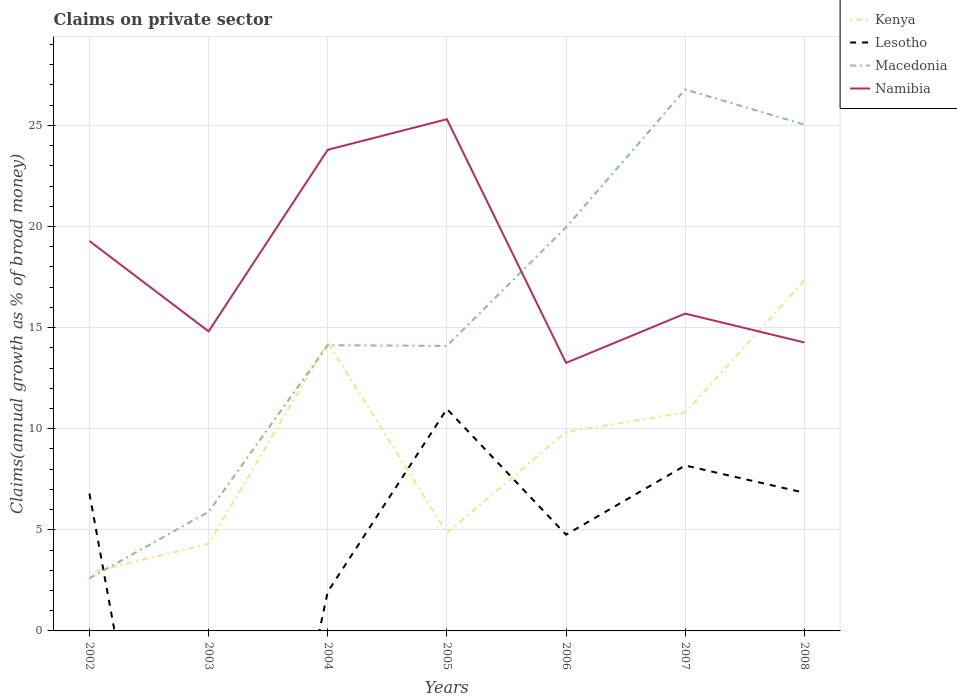How many different coloured lines are there?
Make the answer very short. 4. Is the number of lines equal to the number of legend labels?
Provide a succinct answer. No. Across all years, what is the maximum percentage of broad money claimed on private sector in Macedonia?
Keep it short and to the point. 2.6. What is the total percentage of broad money claimed on private sector in Lesotho in the graph?
Provide a short and direct response. -9.04. What is the difference between the highest and the second highest percentage of broad money claimed on private sector in Namibia?
Make the answer very short. 12.05. What is the difference between the highest and the lowest percentage of broad money claimed on private sector in Kenya?
Keep it short and to the point. 4. Is the percentage of broad money claimed on private sector in Kenya strictly greater than the percentage of broad money claimed on private sector in Lesotho over the years?
Provide a succinct answer. No. How many lines are there?
Ensure brevity in your answer.  4. How many years are there in the graph?
Provide a succinct answer. 7. Are the values on the major ticks of Y-axis written in scientific E-notation?
Provide a short and direct response. No. How are the legend labels stacked?
Give a very brief answer. Vertical. What is the title of the graph?
Your answer should be compact. Claims on private sector. What is the label or title of the Y-axis?
Give a very brief answer. Claims(annual growth as % of broad money). What is the Claims(annual growth as % of broad money) of Kenya in 2002?
Provide a short and direct response. 2.88. What is the Claims(annual growth as % of broad money) of Lesotho in 2002?
Give a very brief answer. 6.79. What is the Claims(annual growth as % of broad money) of Macedonia in 2002?
Your response must be concise. 2.6. What is the Claims(annual growth as % of broad money) of Namibia in 2002?
Make the answer very short. 19.28. What is the Claims(annual growth as % of broad money) in Kenya in 2003?
Your answer should be compact. 4.31. What is the Claims(annual growth as % of broad money) of Lesotho in 2003?
Offer a very short reply. 0. What is the Claims(annual growth as % of broad money) in Macedonia in 2003?
Your answer should be very brief. 5.89. What is the Claims(annual growth as % of broad money) in Namibia in 2003?
Offer a terse response. 14.81. What is the Claims(annual growth as % of broad money) in Kenya in 2004?
Give a very brief answer. 14.27. What is the Claims(annual growth as % of broad money) of Lesotho in 2004?
Ensure brevity in your answer.  1.94. What is the Claims(annual growth as % of broad money) of Macedonia in 2004?
Keep it short and to the point. 14.13. What is the Claims(annual growth as % of broad money) in Namibia in 2004?
Your answer should be compact. 23.79. What is the Claims(annual growth as % of broad money) of Kenya in 2005?
Your answer should be very brief. 4.84. What is the Claims(annual growth as % of broad money) of Lesotho in 2005?
Give a very brief answer. 10.98. What is the Claims(annual growth as % of broad money) of Macedonia in 2005?
Offer a very short reply. 14.1. What is the Claims(annual growth as % of broad money) in Namibia in 2005?
Your answer should be compact. 25.31. What is the Claims(annual growth as % of broad money) of Kenya in 2006?
Provide a succinct answer. 9.84. What is the Claims(annual growth as % of broad money) in Lesotho in 2006?
Provide a short and direct response. 4.76. What is the Claims(annual growth as % of broad money) in Macedonia in 2006?
Provide a succinct answer. 19.96. What is the Claims(annual growth as % of broad money) of Namibia in 2006?
Offer a very short reply. 13.26. What is the Claims(annual growth as % of broad money) of Kenya in 2007?
Provide a succinct answer. 10.8. What is the Claims(annual growth as % of broad money) in Lesotho in 2007?
Provide a short and direct response. 8.18. What is the Claims(annual growth as % of broad money) in Macedonia in 2007?
Offer a very short reply. 26.78. What is the Claims(annual growth as % of broad money) in Namibia in 2007?
Provide a short and direct response. 15.69. What is the Claims(annual growth as % of broad money) in Kenya in 2008?
Your answer should be very brief. 17.33. What is the Claims(annual growth as % of broad money) of Lesotho in 2008?
Provide a short and direct response. 6.83. What is the Claims(annual growth as % of broad money) in Macedonia in 2008?
Give a very brief answer. 25.04. What is the Claims(annual growth as % of broad money) in Namibia in 2008?
Offer a very short reply. 14.27. Across all years, what is the maximum Claims(annual growth as % of broad money) of Kenya?
Ensure brevity in your answer.  17.33. Across all years, what is the maximum Claims(annual growth as % of broad money) in Lesotho?
Your answer should be compact. 10.98. Across all years, what is the maximum Claims(annual growth as % of broad money) in Macedonia?
Offer a terse response. 26.78. Across all years, what is the maximum Claims(annual growth as % of broad money) in Namibia?
Offer a terse response. 25.31. Across all years, what is the minimum Claims(annual growth as % of broad money) in Kenya?
Offer a terse response. 2.88. Across all years, what is the minimum Claims(annual growth as % of broad money) in Lesotho?
Your response must be concise. 0. Across all years, what is the minimum Claims(annual growth as % of broad money) of Macedonia?
Make the answer very short. 2.6. Across all years, what is the minimum Claims(annual growth as % of broad money) of Namibia?
Give a very brief answer. 13.26. What is the total Claims(annual growth as % of broad money) in Kenya in the graph?
Offer a terse response. 64.27. What is the total Claims(annual growth as % of broad money) of Lesotho in the graph?
Your answer should be compact. 39.48. What is the total Claims(annual growth as % of broad money) in Macedonia in the graph?
Make the answer very short. 108.5. What is the total Claims(annual growth as % of broad money) in Namibia in the graph?
Your answer should be compact. 126.41. What is the difference between the Claims(annual growth as % of broad money) of Kenya in 2002 and that in 2003?
Provide a succinct answer. -1.42. What is the difference between the Claims(annual growth as % of broad money) of Macedonia in 2002 and that in 2003?
Offer a terse response. -3.29. What is the difference between the Claims(annual growth as % of broad money) in Namibia in 2002 and that in 2003?
Give a very brief answer. 4.47. What is the difference between the Claims(annual growth as % of broad money) in Kenya in 2002 and that in 2004?
Make the answer very short. -11.39. What is the difference between the Claims(annual growth as % of broad money) of Lesotho in 2002 and that in 2004?
Your response must be concise. 4.86. What is the difference between the Claims(annual growth as % of broad money) in Macedonia in 2002 and that in 2004?
Ensure brevity in your answer.  -11.53. What is the difference between the Claims(annual growth as % of broad money) of Namibia in 2002 and that in 2004?
Make the answer very short. -4.51. What is the difference between the Claims(annual growth as % of broad money) of Kenya in 2002 and that in 2005?
Offer a terse response. -1.96. What is the difference between the Claims(annual growth as % of broad money) of Lesotho in 2002 and that in 2005?
Make the answer very short. -4.18. What is the difference between the Claims(annual growth as % of broad money) in Macedonia in 2002 and that in 2005?
Keep it short and to the point. -11.5. What is the difference between the Claims(annual growth as % of broad money) in Namibia in 2002 and that in 2005?
Keep it short and to the point. -6.02. What is the difference between the Claims(annual growth as % of broad money) of Kenya in 2002 and that in 2006?
Your response must be concise. -6.95. What is the difference between the Claims(annual growth as % of broad money) of Lesotho in 2002 and that in 2006?
Your answer should be compact. 2.03. What is the difference between the Claims(annual growth as % of broad money) in Macedonia in 2002 and that in 2006?
Provide a short and direct response. -17.36. What is the difference between the Claims(annual growth as % of broad money) of Namibia in 2002 and that in 2006?
Provide a short and direct response. 6.03. What is the difference between the Claims(annual growth as % of broad money) in Kenya in 2002 and that in 2007?
Provide a short and direct response. -7.92. What is the difference between the Claims(annual growth as % of broad money) in Lesotho in 2002 and that in 2007?
Provide a succinct answer. -1.39. What is the difference between the Claims(annual growth as % of broad money) in Macedonia in 2002 and that in 2007?
Offer a terse response. -24.18. What is the difference between the Claims(annual growth as % of broad money) of Namibia in 2002 and that in 2007?
Keep it short and to the point. 3.59. What is the difference between the Claims(annual growth as % of broad money) of Kenya in 2002 and that in 2008?
Provide a short and direct response. -14.44. What is the difference between the Claims(annual growth as % of broad money) in Lesotho in 2002 and that in 2008?
Provide a short and direct response. -0.04. What is the difference between the Claims(annual growth as % of broad money) of Macedonia in 2002 and that in 2008?
Give a very brief answer. -22.44. What is the difference between the Claims(annual growth as % of broad money) in Namibia in 2002 and that in 2008?
Your answer should be compact. 5.02. What is the difference between the Claims(annual growth as % of broad money) of Kenya in 2003 and that in 2004?
Offer a terse response. -9.96. What is the difference between the Claims(annual growth as % of broad money) of Macedonia in 2003 and that in 2004?
Your answer should be compact. -8.24. What is the difference between the Claims(annual growth as % of broad money) of Namibia in 2003 and that in 2004?
Keep it short and to the point. -8.98. What is the difference between the Claims(annual growth as % of broad money) of Kenya in 2003 and that in 2005?
Your answer should be very brief. -0.54. What is the difference between the Claims(annual growth as % of broad money) of Macedonia in 2003 and that in 2005?
Keep it short and to the point. -8.2. What is the difference between the Claims(annual growth as % of broad money) of Namibia in 2003 and that in 2005?
Ensure brevity in your answer.  -10.49. What is the difference between the Claims(annual growth as % of broad money) of Kenya in 2003 and that in 2006?
Offer a very short reply. -5.53. What is the difference between the Claims(annual growth as % of broad money) in Macedonia in 2003 and that in 2006?
Keep it short and to the point. -14.07. What is the difference between the Claims(annual growth as % of broad money) of Namibia in 2003 and that in 2006?
Offer a terse response. 1.56. What is the difference between the Claims(annual growth as % of broad money) of Kenya in 2003 and that in 2007?
Make the answer very short. -6.49. What is the difference between the Claims(annual growth as % of broad money) of Macedonia in 2003 and that in 2007?
Offer a terse response. -20.89. What is the difference between the Claims(annual growth as % of broad money) in Namibia in 2003 and that in 2007?
Offer a terse response. -0.88. What is the difference between the Claims(annual growth as % of broad money) in Kenya in 2003 and that in 2008?
Make the answer very short. -13.02. What is the difference between the Claims(annual growth as % of broad money) in Macedonia in 2003 and that in 2008?
Offer a terse response. -19.15. What is the difference between the Claims(annual growth as % of broad money) of Namibia in 2003 and that in 2008?
Provide a succinct answer. 0.55. What is the difference between the Claims(annual growth as % of broad money) of Kenya in 2004 and that in 2005?
Your answer should be compact. 9.43. What is the difference between the Claims(annual growth as % of broad money) in Lesotho in 2004 and that in 2005?
Ensure brevity in your answer.  -9.04. What is the difference between the Claims(annual growth as % of broad money) in Macedonia in 2004 and that in 2005?
Offer a very short reply. 0.03. What is the difference between the Claims(annual growth as % of broad money) in Namibia in 2004 and that in 2005?
Provide a succinct answer. -1.51. What is the difference between the Claims(annual growth as % of broad money) of Kenya in 2004 and that in 2006?
Your response must be concise. 4.43. What is the difference between the Claims(annual growth as % of broad money) of Lesotho in 2004 and that in 2006?
Your response must be concise. -2.82. What is the difference between the Claims(annual growth as % of broad money) in Macedonia in 2004 and that in 2006?
Make the answer very short. -5.83. What is the difference between the Claims(annual growth as % of broad money) in Namibia in 2004 and that in 2006?
Keep it short and to the point. 10.54. What is the difference between the Claims(annual growth as % of broad money) of Kenya in 2004 and that in 2007?
Provide a succinct answer. 3.47. What is the difference between the Claims(annual growth as % of broad money) of Lesotho in 2004 and that in 2007?
Ensure brevity in your answer.  -6.24. What is the difference between the Claims(annual growth as % of broad money) in Macedonia in 2004 and that in 2007?
Ensure brevity in your answer.  -12.65. What is the difference between the Claims(annual growth as % of broad money) of Namibia in 2004 and that in 2007?
Keep it short and to the point. 8.1. What is the difference between the Claims(annual growth as % of broad money) of Kenya in 2004 and that in 2008?
Your answer should be compact. -3.06. What is the difference between the Claims(annual growth as % of broad money) in Lesotho in 2004 and that in 2008?
Make the answer very short. -4.9. What is the difference between the Claims(annual growth as % of broad money) in Macedonia in 2004 and that in 2008?
Provide a succinct answer. -10.91. What is the difference between the Claims(annual growth as % of broad money) in Namibia in 2004 and that in 2008?
Give a very brief answer. 9.53. What is the difference between the Claims(annual growth as % of broad money) of Kenya in 2005 and that in 2006?
Your response must be concise. -4.99. What is the difference between the Claims(annual growth as % of broad money) in Lesotho in 2005 and that in 2006?
Your answer should be compact. 6.22. What is the difference between the Claims(annual growth as % of broad money) in Macedonia in 2005 and that in 2006?
Provide a succinct answer. -5.86. What is the difference between the Claims(annual growth as % of broad money) of Namibia in 2005 and that in 2006?
Provide a short and direct response. 12.05. What is the difference between the Claims(annual growth as % of broad money) in Kenya in 2005 and that in 2007?
Make the answer very short. -5.96. What is the difference between the Claims(annual growth as % of broad money) of Lesotho in 2005 and that in 2007?
Your answer should be very brief. 2.8. What is the difference between the Claims(annual growth as % of broad money) of Macedonia in 2005 and that in 2007?
Keep it short and to the point. -12.68. What is the difference between the Claims(annual growth as % of broad money) of Namibia in 2005 and that in 2007?
Make the answer very short. 9.61. What is the difference between the Claims(annual growth as % of broad money) in Kenya in 2005 and that in 2008?
Ensure brevity in your answer.  -12.48. What is the difference between the Claims(annual growth as % of broad money) of Lesotho in 2005 and that in 2008?
Make the answer very short. 4.14. What is the difference between the Claims(annual growth as % of broad money) in Macedonia in 2005 and that in 2008?
Ensure brevity in your answer.  -10.94. What is the difference between the Claims(annual growth as % of broad money) in Namibia in 2005 and that in 2008?
Give a very brief answer. 11.04. What is the difference between the Claims(annual growth as % of broad money) in Kenya in 2006 and that in 2007?
Your answer should be very brief. -0.96. What is the difference between the Claims(annual growth as % of broad money) of Lesotho in 2006 and that in 2007?
Provide a succinct answer. -3.42. What is the difference between the Claims(annual growth as % of broad money) of Macedonia in 2006 and that in 2007?
Give a very brief answer. -6.82. What is the difference between the Claims(annual growth as % of broad money) of Namibia in 2006 and that in 2007?
Provide a succinct answer. -2.44. What is the difference between the Claims(annual growth as % of broad money) of Kenya in 2006 and that in 2008?
Make the answer very short. -7.49. What is the difference between the Claims(annual growth as % of broad money) of Lesotho in 2006 and that in 2008?
Your response must be concise. -2.07. What is the difference between the Claims(annual growth as % of broad money) in Macedonia in 2006 and that in 2008?
Your answer should be compact. -5.08. What is the difference between the Claims(annual growth as % of broad money) of Namibia in 2006 and that in 2008?
Offer a very short reply. -1.01. What is the difference between the Claims(annual growth as % of broad money) in Kenya in 2007 and that in 2008?
Your answer should be compact. -6.53. What is the difference between the Claims(annual growth as % of broad money) in Lesotho in 2007 and that in 2008?
Your answer should be compact. 1.35. What is the difference between the Claims(annual growth as % of broad money) of Macedonia in 2007 and that in 2008?
Give a very brief answer. 1.74. What is the difference between the Claims(annual growth as % of broad money) of Namibia in 2007 and that in 2008?
Offer a very short reply. 1.43. What is the difference between the Claims(annual growth as % of broad money) of Kenya in 2002 and the Claims(annual growth as % of broad money) of Macedonia in 2003?
Ensure brevity in your answer.  -3.01. What is the difference between the Claims(annual growth as % of broad money) in Kenya in 2002 and the Claims(annual growth as % of broad money) in Namibia in 2003?
Offer a terse response. -11.93. What is the difference between the Claims(annual growth as % of broad money) in Lesotho in 2002 and the Claims(annual growth as % of broad money) in Macedonia in 2003?
Provide a succinct answer. 0.9. What is the difference between the Claims(annual growth as % of broad money) in Lesotho in 2002 and the Claims(annual growth as % of broad money) in Namibia in 2003?
Make the answer very short. -8.02. What is the difference between the Claims(annual growth as % of broad money) in Macedonia in 2002 and the Claims(annual growth as % of broad money) in Namibia in 2003?
Offer a terse response. -12.21. What is the difference between the Claims(annual growth as % of broad money) of Kenya in 2002 and the Claims(annual growth as % of broad money) of Lesotho in 2004?
Provide a short and direct response. 0.95. What is the difference between the Claims(annual growth as % of broad money) in Kenya in 2002 and the Claims(annual growth as % of broad money) in Macedonia in 2004?
Give a very brief answer. -11.25. What is the difference between the Claims(annual growth as % of broad money) of Kenya in 2002 and the Claims(annual growth as % of broad money) of Namibia in 2004?
Provide a short and direct response. -20.91. What is the difference between the Claims(annual growth as % of broad money) in Lesotho in 2002 and the Claims(annual growth as % of broad money) in Macedonia in 2004?
Offer a very short reply. -7.34. What is the difference between the Claims(annual growth as % of broad money) of Lesotho in 2002 and the Claims(annual growth as % of broad money) of Namibia in 2004?
Your answer should be compact. -17. What is the difference between the Claims(annual growth as % of broad money) of Macedonia in 2002 and the Claims(annual growth as % of broad money) of Namibia in 2004?
Keep it short and to the point. -21.19. What is the difference between the Claims(annual growth as % of broad money) in Kenya in 2002 and the Claims(annual growth as % of broad money) in Lesotho in 2005?
Your answer should be compact. -8.09. What is the difference between the Claims(annual growth as % of broad money) of Kenya in 2002 and the Claims(annual growth as % of broad money) of Macedonia in 2005?
Provide a succinct answer. -11.21. What is the difference between the Claims(annual growth as % of broad money) in Kenya in 2002 and the Claims(annual growth as % of broad money) in Namibia in 2005?
Your answer should be compact. -22.42. What is the difference between the Claims(annual growth as % of broad money) of Lesotho in 2002 and the Claims(annual growth as % of broad money) of Macedonia in 2005?
Provide a short and direct response. -7.3. What is the difference between the Claims(annual growth as % of broad money) of Lesotho in 2002 and the Claims(annual growth as % of broad money) of Namibia in 2005?
Your answer should be very brief. -18.51. What is the difference between the Claims(annual growth as % of broad money) of Macedonia in 2002 and the Claims(annual growth as % of broad money) of Namibia in 2005?
Give a very brief answer. -22.7. What is the difference between the Claims(annual growth as % of broad money) of Kenya in 2002 and the Claims(annual growth as % of broad money) of Lesotho in 2006?
Make the answer very short. -1.88. What is the difference between the Claims(annual growth as % of broad money) in Kenya in 2002 and the Claims(annual growth as % of broad money) in Macedonia in 2006?
Give a very brief answer. -17.08. What is the difference between the Claims(annual growth as % of broad money) of Kenya in 2002 and the Claims(annual growth as % of broad money) of Namibia in 2006?
Ensure brevity in your answer.  -10.37. What is the difference between the Claims(annual growth as % of broad money) in Lesotho in 2002 and the Claims(annual growth as % of broad money) in Macedonia in 2006?
Your answer should be very brief. -13.17. What is the difference between the Claims(annual growth as % of broad money) of Lesotho in 2002 and the Claims(annual growth as % of broad money) of Namibia in 2006?
Offer a terse response. -6.46. What is the difference between the Claims(annual growth as % of broad money) of Macedonia in 2002 and the Claims(annual growth as % of broad money) of Namibia in 2006?
Give a very brief answer. -10.65. What is the difference between the Claims(annual growth as % of broad money) in Kenya in 2002 and the Claims(annual growth as % of broad money) in Lesotho in 2007?
Make the answer very short. -5.3. What is the difference between the Claims(annual growth as % of broad money) of Kenya in 2002 and the Claims(annual growth as % of broad money) of Macedonia in 2007?
Make the answer very short. -23.9. What is the difference between the Claims(annual growth as % of broad money) of Kenya in 2002 and the Claims(annual growth as % of broad money) of Namibia in 2007?
Offer a very short reply. -12.81. What is the difference between the Claims(annual growth as % of broad money) of Lesotho in 2002 and the Claims(annual growth as % of broad money) of Macedonia in 2007?
Give a very brief answer. -19.99. What is the difference between the Claims(annual growth as % of broad money) in Lesotho in 2002 and the Claims(annual growth as % of broad money) in Namibia in 2007?
Give a very brief answer. -8.9. What is the difference between the Claims(annual growth as % of broad money) of Macedonia in 2002 and the Claims(annual growth as % of broad money) of Namibia in 2007?
Offer a very short reply. -13.09. What is the difference between the Claims(annual growth as % of broad money) in Kenya in 2002 and the Claims(annual growth as % of broad money) in Lesotho in 2008?
Provide a short and direct response. -3.95. What is the difference between the Claims(annual growth as % of broad money) in Kenya in 2002 and the Claims(annual growth as % of broad money) in Macedonia in 2008?
Your answer should be very brief. -22.16. What is the difference between the Claims(annual growth as % of broad money) in Kenya in 2002 and the Claims(annual growth as % of broad money) in Namibia in 2008?
Provide a short and direct response. -11.38. What is the difference between the Claims(annual growth as % of broad money) in Lesotho in 2002 and the Claims(annual growth as % of broad money) in Macedonia in 2008?
Make the answer very short. -18.25. What is the difference between the Claims(annual growth as % of broad money) in Lesotho in 2002 and the Claims(annual growth as % of broad money) in Namibia in 2008?
Offer a very short reply. -7.47. What is the difference between the Claims(annual growth as % of broad money) of Macedonia in 2002 and the Claims(annual growth as % of broad money) of Namibia in 2008?
Your answer should be very brief. -11.66. What is the difference between the Claims(annual growth as % of broad money) of Kenya in 2003 and the Claims(annual growth as % of broad money) of Lesotho in 2004?
Offer a very short reply. 2.37. What is the difference between the Claims(annual growth as % of broad money) of Kenya in 2003 and the Claims(annual growth as % of broad money) of Macedonia in 2004?
Your response must be concise. -9.82. What is the difference between the Claims(annual growth as % of broad money) in Kenya in 2003 and the Claims(annual growth as % of broad money) in Namibia in 2004?
Provide a succinct answer. -19.49. What is the difference between the Claims(annual growth as % of broad money) of Macedonia in 2003 and the Claims(annual growth as % of broad money) of Namibia in 2004?
Give a very brief answer. -17.9. What is the difference between the Claims(annual growth as % of broad money) in Kenya in 2003 and the Claims(annual growth as % of broad money) in Lesotho in 2005?
Your answer should be compact. -6.67. What is the difference between the Claims(annual growth as % of broad money) of Kenya in 2003 and the Claims(annual growth as % of broad money) of Macedonia in 2005?
Offer a terse response. -9.79. What is the difference between the Claims(annual growth as % of broad money) in Kenya in 2003 and the Claims(annual growth as % of broad money) in Namibia in 2005?
Your answer should be very brief. -21. What is the difference between the Claims(annual growth as % of broad money) of Macedonia in 2003 and the Claims(annual growth as % of broad money) of Namibia in 2005?
Offer a terse response. -19.41. What is the difference between the Claims(annual growth as % of broad money) in Kenya in 2003 and the Claims(annual growth as % of broad money) in Lesotho in 2006?
Provide a succinct answer. -0.45. What is the difference between the Claims(annual growth as % of broad money) of Kenya in 2003 and the Claims(annual growth as % of broad money) of Macedonia in 2006?
Ensure brevity in your answer.  -15.65. What is the difference between the Claims(annual growth as % of broad money) of Kenya in 2003 and the Claims(annual growth as % of broad money) of Namibia in 2006?
Your response must be concise. -8.95. What is the difference between the Claims(annual growth as % of broad money) of Macedonia in 2003 and the Claims(annual growth as % of broad money) of Namibia in 2006?
Provide a succinct answer. -7.36. What is the difference between the Claims(annual growth as % of broad money) in Kenya in 2003 and the Claims(annual growth as % of broad money) in Lesotho in 2007?
Your response must be concise. -3.87. What is the difference between the Claims(annual growth as % of broad money) in Kenya in 2003 and the Claims(annual growth as % of broad money) in Macedonia in 2007?
Your response must be concise. -22.47. What is the difference between the Claims(annual growth as % of broad money) of Kenya in 2003 and the Claims(annual growth as % of broad money) of Namibia in 2007?
Provide a short and direct response. -11.39. What is the difference between the Claims(annual growth as % of broad money) in Macedonia in 2003 and the Claims(annual growth as % of broad money) in Namibia in 2007?
Your response must be concise. -9.8. What is the difference between the Claims(annual growth as % of broad money) in Kenya in 2003 and the Claims(annual growth as % of broad money) in Lesotho in 2008?
Give a very brief answer. -2.53. What is the difference between the Claims(annual growth as % of broad money) of Kenya in 2003 and the Claims(annual growth as % of broad money) of Macedonia in 2008?
Make the answer very short. -20.73. What is the difference between the Claims(annual growth as % of broad money) in Kenya in 2003 and the Claims(annual growth as % of broad money) in Namibia in 2008?
Offer a very short reply. -9.96. What is the difference between the Claims(annual growth as % of broad money) of Macedonia in 2003 and the Claims(annual growth as % of broad money) of Namibia in 2008?
Provide a succinct answer. -8.37. What is the difference between the Claims(annual growth as % of broad money) of Kenya in 2004 and the Claims(annual growth as % of broad money) of Lesotho in 2005?
Your answer should be compact. 3.29. What is the difference between the Claims(annual growth as % of broad money) of Kenya in 2004 and the Claims(annual growth as % of broad money) of Macedonia in 2005?
Provide a short and direct response. 0.17. What is the difference between the Claims(annual growth as % of broad money) of Kenya in 2004 and the Claims(annual growth as % of broad money) of Namibia in 2005?
Offer a very short reply. -11.04. What is the difference between the Claims(annual growth as % of broad money) of Lesotho in 2004 and the Claims(annual growth as % of broad money) of Macedonia in 2005?
Provide a succinct answer. -12.16. What is the difference between the Claims(annual growth as % of broad money) in Lesotho in 2004 and the Claims(annual growth as % of broad money) in Namibia in 2005?
Provide a succinct answer. -23.37. What is the difference between the Claims(annual growth as % of broad money) of Macedonia in 2004 and the Claims(annual growth as % of broad money) of Namibia in 2005?
Make the answer very short. -11.18. What is the difference between the Claims(annual growth as % of broad money) in Kenya in 2004 and the Claims(annual growth as % of broad money) in Lesotho in 2006?
Provide a succinct answer. 9.51. What is the difference between the Claims(annual growth as % of broad money) in Kenya in 2004 and the Claims(annual growth as % of broad money) in Macedonia in 2006?
Provide a succinct answer. -5.69. What is the difference between the Claims(annual growth as % of broad money) of Kenya in 2004 and the Claims(annual growth as % of broad money) of Namibia in 2006?
Offer a very short reply. 1.01. What is the difference between the Claims(annual growth as % of broad money) in Lesotho in 2004 and the Claims(annual growth as % of broad money) in Macedonia in 2006?
Keep it short and to the point. -18.02. What is the difference between the Claims(annual growth as % of broad money) in Lesotho in 2004 and the Claims(annual growth as % of broad money) in Namibia in 2006?
Provide a succinct answer. -11.32. What is the difference between the Claims(annual growth as % of broad money) in Macedonia in 2004 and the Claims(annual growth as % of broad money) in Namibia in 2006?
Make the answer very short. 0.87. What is the difference between the Claims(annual growth as % of broad money) in Kenya in 2004 and the Claims(annual growth as % of broad money) in Lesotho in 2007?
Provide a short and direct response. 6.09. What is the difference between the Claims(annual growth as % of broad money) in Kenya in 2004 and the Claims(annual growth as % of broad money) in Macedonia in 2007?
Your answer should be compact. -12.51. What is the difference between the Claims(annual growth as % of broad money) of Kenya in 2004 and the Claims(annual growth as % of broad money) of Namibia in 2007?
Provide a short and direct response. -1.42. What is the difference between the Claims(annual growth as % of broad money) of Lesotho in 2004 and the Claims(annual growth as % of broad money) of Macedonia in 2007?
Keep it short and to the point. -24.84. What is the difference between the Claims(annual growth as % of broad money) of Lesotho in 2004 and the Claims(annual growth as % of broad money) of Namibia in 2007?
Keep it short and to the point. -13.76. What is the difference between the Claims(annual growth as % of broad money) in Macedonia in 2004 and the Claims(annual growth as % of broad money) in Namibia in 2007?
Keep it short and to the point. -1.56. What is the difference between the Claims(annual growth as % of broad money) in Kenya in 2004 and the Claims(annual growth as % of broad money) in Lesotho in 2008?
Your response must be concise. 7.44. What is the difference between the Claims(annual growth as % of broad money) of Kenya in 2004 and the Claims(annual growth as % of broad money) of Macedonia in 2008?
Keep it short and to the point. -10.77. What is the difference between the Claims(annual growth as % of broad money) of Kenya in 2004 and the Claims(annual growth as % of broad money) of Namibia in 2008?
Offer a terse response. 0.01. What is the difference between the Claims(annual growth as % of broad money) in Lesotho in 2004 and the Claims(annual growth as % of broad money) in Macedonia in 2008?
Your answer should be very brief. -23.1. What is the difference between the Claims(annual growth as % of broad money) in Lesotho in 2004 and the Claims(annual growth as % of broad money) in Namibia in 2008?
Give a very brief answer. -12.33. What is the difference between the Claims(annual growth as % of broad money) of Macedonia in 2004 and the Claims(annual growth as % of broad money) of Namibia in 2008?
Your response must be concise. -0.14. What is the difference between the Claims(annual growth as % of broad money) of Kenya in 2005 and the Claims(annual growth as % of broad money) of Lesotho in 2006?
Your response must be concise. 0.08. What is the difference between the Claims(annual growth as % of broad money) in Kenya in 2005 and the Claims(annual growth as % of broad money) in Macedonia in 2006?
Provide a short and direct response. -15.12. What is the difference between the Claims(annual growth as % of broad money) in Kenya in 2005 and the Claims(annual growth as % of broad money) in Namibia in 2006?
Keep it short and to the point. -8.41. What is the difference between the Claims(annual growth as % of broad money) of Lesotho in 2005 and the Claims(annual growth as % of broad money) of Macedonia in 2006?
Your answer should be compact. -8.98. What is the difference between the Claims(annual growth as % of broad money) in Lesotho in 2005 and the Claims(annual growth as % of broad money) in Namibia in 2006?
Your response must be concise. -2.28. What is the difference between the Claims(annual growth as % of broad money) of Macedonia in 2005 and the Claims(annual growth as % of broad money) of Namibia in 2006?
Offer a terse response. 0.84. What is the difference between the Claims(annual growth as % of broad money) of Kenya in 2005 and the Claims(annual growth as % of broad money) of Lesotho in 2007?
Your response must be concise. -3.34. What is the difference between the Claims(annual growth as % of broad money) in Kenya in 2005 and the Claims(annual growth as % of broad money) in Macedonia in 2007?
Provide a short and direct response. -21.93. What is the difference between the Claims(annual growth as % of broad money) in Kenya in 2005 and the Claims(annual growth as % of broad money) in Namibia in 2007?
Provide a succinct answer. -10.85. What is the difference between the Claims(annual growth as % of broad money) of Lesotho in 2005 and the Claims(annual growth as % of broad money) of Macedonia in 2007?
Your answer should be compact. -15.8. What is the difference between the Claims(annual growth as % of broad money) of Lesotho in 2005 and the Claims(annual growth as % of broad money) of Namibia in 2007?
Offer a terse response. -4.72. What is the difference between the Claims(annual growth as % of broad money) of Macedonia in 2005 and the Claims(annual growth as % of broad money) of Namibia in 2007?
Ensure brevity in your answer.  -1.6. What is the difference between the Claims(annual growth as % of broad money) of Kenya in 2005 and the Claims(annual growth as % of broad money) of Lesotho in 2008?
Offer a very short reply. -1.99. What is the difference between the Claims(annual growth as % of broad money) of Kenya in 2005 and the Claims(annual growth as % of broad money) of Macedonia in 2008?
Provide a short and direct response. -20.2. What is the difference between the Claims(annual growth as % of broad money) in Kenya in 2005 and the Claims(annual growth as % of broad money) in Namibia in 2008?
Ensure brevity in your answer.  -9.42. What is the difference between the Claims(annual growth as % of broad money) of Lesotho in 2005 and the Claims(annual growth as % of broad money) of Macedonia in 2008?
Give a very brief answer. -14.06. What is the difference between the Claims(annual growth as % of broad money) of Lesotho in 2005 and the Claims(annual growth as % of broad money) of Namibia in 2008?
Offer a terse response. -3.29. What is the difference between the Claims(annual growth as % of broad money) of Macedonia in 2005 and the Claims(annual growth as % of broad money) of Namibia in 2008?
Make the answer very short. -0.17. What is the difference between the Claims(annual growth as % of broad money) in Kenya in 2006 and the Claims(annual growth as % of broad money) in Lesotho in 2007?
Offer a terse response. 1.66. What is the difference between the Claims(annual growth as % of broad money) in Kenya in 2006 and the Claims(annual growth as % of broad money) in Macedonia in 2007?
Your response must be concise. -16.94. What is the difference between the Claims(annual growth as % of broad money) of Kenya in 2006 and the Claims(annual growth as % of broad money) of Namibia in 2007?
Your answer should be compact. -5.86. What is the difference between the Claims(annual growth as % of broad money) of Lesotho in 2006 and the Claims(annual growth as % of broad money) of Macedonia in 2007?
Give a very brief answer. -22.02. What is the difference between the Claims(annual growth as % of broad money) of Lesotho in 2006 and the Claims(annual growth as % of broad money) of Namibia in 2007?
Make the answer very short. -10.93. What is the difference between the Claims(annual growth as % of broad money) in Macedonia in 2006 and the Claims(annual growth as % of broad money) in Namibia in 2007?
Your answer should be compact. 4.27. What is the difference between the Claims(annual growth as % of broad money) in Kenya in 2006 and the Claims(annual growth as % of broad money) in Lesotho in 2008?
Offer a terse response. 3. What is the difference between the Claims(annual growth as % of broad money) in Kenya in 2006 and the Claims(annual growth as % of broad money) in Macedonia in 2008?
Keep it short and to the point. -15.2. What is the difference between the Claims(annual growth as % of broad money) of Kenya in 2006 and the Claims(annual growth as % of broad money) of Namibia in 2008?
Your answer should be compact. -4.43. What is the difference between the Claims(annual growth as % of broad money) in Lesotho in 2006 and the Claims(annual growth as % of broad money) in Macedonia in 2008?
Offer a terse response. -20.28. What is the difference between the Claims(annual growth as % of broad money) of Lesotho in 2006 and the Claims(annual growth as % of broad money) of Namibia in 2008?
Provide a succinct answer. -9.51. What is the difference between the Claims(annual growth as % of broad money) in Macedonia in 2006 and the Claims(annual growth as % of broad money) in Namibia in 2008?
Offer a very short reply. 5.69. What is the difference between the Claims(annual growth as % of broad money) in Kenya in 2007 and the Claims(annual growth as % of broad money) in Lesotho in 2008?
Keep it short and to the point. 3.97. What is the difference between the Claims(annual growth as % of broad money) in Kenya in 2007 and the Claims(annual growth as % of broad money) in Macedonia in 2008?
Offer a terse response. -14.24. What is the difference between the Claims(annual growth as % of broad money) in Kenya in 2007 and the Claims(annual growth as % of broad money) in Namibia in 2008?
Ensure brevity in your answer.  -3.46. What is the difference between the Claims(annual growth as % of broad money) of Lesotho in 2007 and the Claims(annual growth as % of broad money) of Macedonia in 2008?
Provide a succinct answer. -16.86. What is the difference between the Claims(annual growth as % of broad money) in Lesotho in 2007 and the Claims(annual growth as % of broad money) in Namibia in 2008?
Offer a very short reply. -6.08. What is the difference between the Claims(annual growth as % of broad money) of Macedonia in 2007 and the Claims(annual growth as % of broad money) of Namibia in 2008?
Your response must be concise. 12.51. What is the average Claims(annual growth as % of broad money) of Kenya per year?
Keep it short and to the point. 9.18. What is the average Claims(annual growth as % of broad money) of Lesotho per year?
Make the answer very short. 5.64. What is the average Claims(annual growth as % of broad money) in Macedonia per year?
Offer a very short reply. 15.5. What is the average Claims(annual growth as % of broad money) of Namibia per year?
Keep it short and to the point. 18.06. In the year 2002, what is the difference between the Claims(annual growth as % of broad money) in Kenya and Claims(annual growth as % of broad money) in Lesotho?
Give a very brief answer. -3.91. In the year 2002, what is the difference between the Claims(annual growth as % of broad money) of Kenya and Claims(annual growth as % of broad money) of Macedonia?
Offer a very short reply. 0.28. In the year 2002, what is the difference between the Claims(annual growth as % of broad money) of Kenya and Claims(annual growth as % of broad money) of Namibia?
Ensure brevity in your answer.  -16.4. In the year 2002, what is the difference between the Claims(annual growth as % of broad money) in Lesotho and Claims(annual growth as % of broad money) in Macedonia?
Make the answer very short. 4.19. In the year 2002, what is the difference between the Claims(annual growth as % of broad money) of Lesotho and Claims(annual growth as % of broad money) of Namibia?
Keep it short and to the point. -12.49. In the year 2002, what is the difference between the Claims(annual growth as % of broad money) of Macedonia and Claims(annual growth as % of broad money) of Namibia?
Your response must be concise. -16.68. In the year 2003, what is the difference between the Claims(annual growth as % of broad money) of Kenya and Claims(annual growth as % of broad money) of Macedonia?
Your answer should be very brief. -1.58. In the year 2003, what is the difference between the Claims(annual growth as % of broad money) in Kenya and Claims(annual growth as % of broad money) in Namibia?
Make the answer very short. -10.51. In the year 2003, what is the difference between the Claims(annual growth as % of broad money) in Macedonia and Claims(annual growth as % of broad money) in Namibia?
Offer a terse response. -8.92. In the year 2004, what is the difference between the Claims(annual growth as % of broad money) of Kenya and Claims(annual growth as % of broad money) of Lesotho?
Provide a succinct answer. 12.33. In the year 2004, what is the difference between the Claims(annual growth as % of broad money) of Kenya and Claims(annual growth as % of broad money) of Macedonia?
Provide a succinct answer. 0.14. In the year 2004, what is the difference between the Claims(annual growth as % of broad money) in Kenya and Claims(annual growth as % of broad money) in Namibia?
Ensure brevity in your answer.  -9.52. In the year 2004, what is the difference between the Claims(annual growth as % of broad money) in Lesotho and Claims(annual growth as % of broad money) in Macedonia?
Your answer should be compact. -12.19. In the year 2004, what is the difference between the Claims(annual growth as % of broad money) of Lesotho and Claims(annual growth as % of broad money) of Namibia?
Keep it short and to the point. -21.86. In the year 2004, what is the difference between the Claims(annual growth as % of broad money) in Macedonia and Claims(annual growth as % of broad money) in Namibia?
Keep it short and to the point. -9.66. In the year 2005, what is the difference between the Claims(annual growth as % of broad money) in Kenya and Claims(annual growth as % of broad money) in Lesotho?
Provide a succinct answer. -6.13. In the year 2005, what is the difference between the Claims(annual growth as % of broad money) in Kenya and Claims(annual growth as % of broad money) in Macedonia?
Keep it short and to the point. -9.25. In the year 2005, what is the difference between the Claims(annual growth as % of broad money) in Kenya and Claims(annual growth as % of broad money) in Namibia?
Offer a terse response. -20.46. In the year 2005, what is the difference between the Claims(annual growth as % of broad money) in Lesotho and Claims(annual growth as % of broad money) in Macedonia?
Your response must be concise. -3.12. In the year 2005, what is the difference between the Claims(annual growth as % of broad money) of Lesotho and Claims(annual growth as % of broad money) of Namibia?
Provide a succinct answer. -14.33. In the year 2005, what is the difference between the Claims(annual growth as % of broad money) in Macedonia and Claims(annual growth as % of broad money) in Namibia?
Provide a short and direct response. -11.21. In the year 2006, what is the difference between the Claims(annual growth as % of broad money) of Kenya and Claims(annual growth as % of broad money) of Lesotho?
Give a very brief answer. 5.08. In the year 2006, what is the difference between the Claims(annual growth as % of broad money) of Kenya and Claims(annual growth as % of broad money) of Macedonia?
Offer a terse response. -10.12. In the year 2006, what is the difference between the Claims(annual growth as % of broad money) in Kenya and Claims(annual growth as % of broad money) in Namibia?
Ensure brevity in your answer.  -3.42. In the year 2006, what is the difference between the Claims(annual growth as % of broad money) in Lesotho and Claims(annual growth as % of broad money) in Macedonia?
Provide a succinct answer. -15.2. In the year 2006, what is the difference between the Claims(annual growth as % of broad money) of Lesotho and Claims(annual growth as % of broad money) of Namibia?
Your answer should be very brief. -8.5. In the year 2006, what is the difference between the Claims(annual growth as % of broad money) of Macedonia and Claims(annual growth as % of broad money) of Namibia?
Offer a very short reply. 6.7. In the year 2007, what is the difference between the Claims(annual growth as % of broad money) in Kenya and Claims(annual growth as % of broad money) in Lesotho?
Provide a succinct answer. 2.62. In the year 2007, what is the difference between the Claims(annual growth as % of broad money) of Kenya and Claims(annual growth as % of broad money) of Macedonia?
Keep it short and to the point. -15.98. In the year 2007, what is the difference between the Claims(annual growth as % of broad money) of Kenya and Claims(annual growth as % of broad money) of Namibia?
Offer a very short reply. -4.89. In the year 2007, what is the difference between the Claims(annual growth as % of broad money) in Lesotho and Claims(annual growth as % of broad money) in Macedonia?
Offer a very short reply. -18.6. In the year 2007, what is the difference between the Claims(annual growth as % of broad money) of Lesotho and Claims(annual growth as % of broad money) of Namibia?
Give a very brief answer. -7.51. In the year 2007, what is the difference between the Claims(annual growth as % of broad money) of Macedonia and Claims(annual growth as % of broad money) of Namibia?
Give a very brief answer. 11.09. In the year 2008, what is the difference between the Claims(annual growth as % of broad money) of Kenya and Claims(annual growth as % of broad money) of Lesotho?
Make the answer very short. 10.49. In the year 2008, what is the difference between the Claims(annual growth as % of broad money) of Kenya and Claims(annual growth as % of broad money) of Macedonia?
Offer a very short reply. -7.71. In the year 2008, what is the difference between the Claims(annual growth as % of broad money) of Kenya and Claims(annual growth as % of broad money) of Namibia?
Make the answer very short. 3.06. In the year 2008, what is the difference between the Claims(annual growth as % of broad money) of Lesotho and Claims(annual growth as % of broad money) of Macedonia?
Keep it short and to the point. -18.21. In the year 2008, what is the difference between the Claims(annual growth as % of broad money) of Lesotho and Claims(annual growth as % of broad money) of Namibia?
Offer a terse response. -7.43. In the year 2008, what is the difference between the Claims(annual growth as % of broad money) in Macedonia and Claims(annual growth as % of broad money) in Namibia?
Offer a very short reply. 10.77. What is the ratio of the Claims(annual growth as % of broad money) of Kenya in 2002 to that in 2003?
Your answer should be compact. 0.67. What is the ratio of the Claims(annual growth as % of broad money) of Macedonia in 2002 to that in 2003?
Provide a short and direct response. 0.44. What is the ratio of the Claims(annual growth as % of broad money) of Namibia in 2002 to that in 2003?
Your response must be concise. 1.3. What is the ratio of the Claims(annual growth as % of broad money) in Kenya in 2002 to that in 2004?
Your answer should be very brief. 0.2. What is the ratio of the Claims(annual growth as % of broad money) in Lesotho in 2002 to that in 2004?
Ensure brevity in your answer.  3.51. What is the ratio of the Claims(annual growth as % of broad money) of Macedonia in 2002 to that in 2004?
Your answer should be very brief. 0.18. What is the ratio of the Claims(annual growth as % of broad money) of Namibia in 2002 to that in 2004?
Provide a succinct answer. 0.81. What is the ratio of the Claims(annual growth as % of broad money) of Kenya in 2002 to that in 2005?
Provide a short and direct response. 0.6. What is the ratio of the Claims(annual growth as % of broad money) in Lesotho in 2002 to that in 2005?
Your answer should be compact. 0.62. What is the ratio of the Claims(annual growth as % of broad money) of Macedonia in 2002 to that in 2005?
Give a very brief answer. 0.18. What is the ratio of the Claims(annual growth as % of broad money) in Namibia in 2002 to that in 2005?
Provide a succinct answer. 0.76. What is the ratio of the Claims(annual growth as % of broad money) in Kenya in 2002 to that in 2006?
Make the answer very short. 0.29. What is the ratio of the Claims(annual growth as % of broad money) in Lesotho in 2002 to that in 2006?
Offer a terse response. 1.43. What is the ratio of the Claims(annual growth as % of broad money) of Macedonia in 2002 to that in 2006?
Provide a succinct answer. 0.13. What is the ratio of the Claims(annual growth as % of broad money) in Namibia in 2002 to that in 2006?
Give a very brief answer. 1.45. What is the ratio of the Claims(annual growth as % of broad money) of Kenya in 2002 to that in 2007?
Offer a very short reply. 0.27. What is the ratio of the Claims(annual growth as % of broad money) in Lesotho in 2002 to that in 2007?
Your answer should be compact. 0.83. What is the ratio of the Claims(annual growth as % of broad money) of Macedonia in 2002 to that in 2007?
Make the answer very short. 0.1. What is the ratio of the Claims(annual growth as % of broad money) in Namibia in 2002 to that in 2007?
Ensure brevity in your answer.  1.23. What is the ratio of the Claims(annual growth as % of broad money) in Kenya in 2002 to that in 2008?
Offer a terse response. 0.17. What is the ratio of the Claims(annual growth as % of broad money) of Macedonia in 2002 to that in 2008?
Make the answer very short. 0.1. What is the ratio of the Claims(annual growth as % of broad money) in Namibia in 2002 to that in 2008?
Make the answer very short. 1.35. What is the ratio of the Claims(annual growth as % of broad money) of Kenya in 2003 to that in 2004?
Ensure brevity in your answer.  0.3. What is the ratio of the Claims(annual growth as % of broad money) in Macedonia in 2003 to that in 2004?
Offer a very short reply. 0.42. What is the ratio of the Claims(annual growth as % of broad money) of Namibia in 2003 to that in 2004?
Your answer should be very brief. 0.62. What is the ratio of the Claims(annual growth as % of broad money) in Kenya in 2003 to that in 2005?
Keep it short and to the point. 0.89. What is the ratio of the Claims(annual growth as % of broad money) of Macedonia in 2003 to that in 2005?
Make the answer very short. 0.42. What is the ratio of the Claims(annual growth as % of broad money) of Namibia in 2003 to that in 2005?
Your response must be concise. 0.59. What is the ratio of the Claims(annual growth as % of broad money) of Kenya in 2003 to that in 2006?
Offer a terse response. 0.44. What is the ratio of the Claims(annual growth as % of broad money) of Macedonia in 2003 to that in 2006?
Give a very brief answer. 0.3. What is the ratio of the Claims(annual growth as % of broad money) in Namibia in 2003 to that in 2006?
Provide a short and direct response. 1.12. What is the ratio of the Claims(annual growth as % of broad money) in Kenya in 2003 to that in 2007?
Provide a succinct answer. 0.4. What is the ratio of the Claims(annual growth as % of broad money) in Macedonia in 2003 to that in 2007?
Make the answer very short. 0.22. What is the ratio of the Claims(annual growth as % of broad money) of Namibia in 2003 to that in 2007?
Provide a short and direct response. 0.94. What is the ratio of the Claims(annual growth as % of broad money) in Kenya in 2003 to that in 2008?
Offer a very short reply. 0.25. What is the ratio of the Claims(annual growth as % of broad money) of Macedonia in 2003 to that in 2008?
Make the answer very short. 0.24. What is the ratio of the Claims(annual growth as % of broad money) in Namibia in 2003 to that in 2008?
Provide a short and direct response. 1.04. What is the ratio of the Claims(annual growth as % of broad money) of Kenya in 2004 to that in 2005?
Give a very brief answer. 2.95. What is the ratio of the Claims(annual growth as % of broad money) of Lesotho in 2004 to that in 2005?
Ensure brevity in your answer.  0.18. What is the ratio of the Claims(annual growth as % of broad money) of Namibia in 2004 to that in 2005?
Offer a very short reply. 0.94. What is the ratio of the Claims(annual growth as % of broad money) in Kenya in 2004 to that in 2006?
Your response must be concise. 1.45. What is the ratio of the Claims(annual growth as % of broad money) in Lesotho in 2004 to that in 2006?
Your response must be concise. 0.41. What is the ratio of the Claims(annual growth as % of broad money) in Macedonia in 2004 to that in 2006?
Give a very brief answer. 0.71. What is the ratio of the Claims(annual growth as % of broad money) of Namibia in 2004 to that in 2006?
Your answer should be compact. 1.8. What is the ratio of the Claims(annual growth as % of broad money) in Kenya in 2004 to that in 2007?
Ensure brevity in your answer.  1.32. What is the ratio of the Claims(annual growth as % of broad money) in Lesotho in 2004 to that in 2007?
Provide a short and direct response. 0.24. What is the ratio of the Claims(annual growth as % of broad money) in Macedonia in 2004 to that in 2007?
Provide a short and direct response. 0.53. What is the ratio of the Claims(annual growth as % of broad money) in Namibia in 2004 to that in 2007?
Provide a short and direct response. 1.52. What is the ratio of the Claims(annual growth as % of broad money) in Kenya in 2004 to that in 2008?
Ensure brevity in your answer.  0.82. What is the ratio of the Claims(annual growth as % of broad money) of Lesotho in 2004 to that in 2008?
Your answer should be compact. 0.28. What is the ratio of the Claims(annual growth as % of broad money) in Macedonia in 2004 to that in 2008?
Offer a very short reply. 0.56. What is the ratio of the Claims(annual growth as % of broad money) of Namibia in 2004 to that in 2008?
Make the answer very short. 1.67. What is the ratio of the Claims(annual growth as % of broad money) of Kenya in 2005 to that in 2006?
Provide a short and direct response. 0.49. What is the ratio of the Claims(annual growth as % of broad money) in Lesotho in 2005 to that in 2006?
Your answer should be compact. 2.31. What is the ratio of the Claims(annual growth as % of broad money) of Macedonia in 2005 to that in 2006?
Offer a very short reply. 0.71. What is the ratio of the Claims(annual growth as % of broad money) in Namibia in 2005 to that in 2006?
Give a very brief answer. 1.91. What is the ratio of the Claims(annual growth as % of broad money) of Kenya in 2005 to that in 2007?
Offer a very short reply. 0.45. What is the ratio of the Claims(annual growth as % of broad money) of Lesotho in 2005 to that in 2007?
Make the answer very short. 1.34. What is the ratio of the Claims(annual growth as % of broad money) in Macedonia in 2005 to that in 2007?
Offer a terse response. 0.53. What is the ratio of the Claims(annual growth as % of broad money) in Namibia in 2005 to that in 2007?
Offer a very short reply. 1.61. What is the ratio of the Claims(annual growth as % of broad money) of Kenya in 2005 to that in 2008?
Provide a succinct answer. 0.28. What is the ratio of the Claims(annual growth as % of broad money) in Lesotho in 2005 to that in 2008?
Offer a very short reply. 1.61. What is the ratio of the Claims(annual growth as % of broad money) in Macedonia in 2005 to that in 2008?
Provide a short and direct response. 0.56. What is the ratio of the Claims(annual growth as % of broad money) of Namibia in 2005 to that in 2008?
Give a very brief answer. 1.77. What is the ratio of the Claims(annual growth as % of broad money) in Kenya in 2006 to that in 2007?
Your answer should be compact. 0.91. What is the ratio of the Claims(annual growth as % of broad money) in Lesotho in 2006 to that in 2007?
Your response must be concise. 0.58. What is the ratio of the Claims(annual growth as % of broad money) of Macedonia in 2006 to that in 2007?
Ensure brevity in your answer.  0.75. What is the ratio of the Claims(annual growth as % of broad money) in Namibia in 2006 to that in 2007?
Your answer should be compact. 0.84. What is the ratio of the Claims(annual growth as % of broad money) of Kenya in 2006 to that in 2008?
Your answer should be very brief. 0.57. What is the ratio of the Claims(annual growth as % of broad money) in Lesotho in 2006 to that in 2008?
Keep it short and to the point. 0.7. What is the ratio of the Claims(annual growth as % of broad money) in Macedonia in 2006 to that in 2008?
Make the answer very short. 0.8. What is the ratio of the Claims(annual growth as % of broad money) in Namibia in 2006 to that in 2008?
Your answer should be very brief. 0.93. What is the ratio of the Claims(annual growth as % of broad money) in Kenya in 2007 to that in 2008?
Give a very brief answer. 0.62. What is the ratio of the Claims(annual growth as % of broad money) in Lesotho in 2007 to that in 2008?
Provide a short and direct response. 1.2. What is the ratio of the Claims(annual growth as % of broad money) of Macedonia in 2007 to that in 2008?
Ensure brevity in your answer.  1.07. What is the ratio of the Claims(annual growth as % of broad money) in Namibia in 2007 to that in 2008?
Give a very brief answer. 1.1. What is the difference between the highest and the second highest Claims(annual growth as % of broad money) of Kenya?
Offer a very short reply. 3.06. What is the difference between the highest and the second highest Claims(annual growth as % of broad money) in Lesotho?
Give a very brief answer. 2.8. What is the difference between the highest and the second highest Claims(annual growth as % of broad money) in Macedonia?
Your answer should be very brief. 1.74. What is the difference between the highest and the second highest Claims(annual growth as % of broad money) in Namibia?
Make the answer very short. 1.51. What is the difference between the highest and the lowest Claims(annual growth as % of broad money) in Kenya?
Your answer should be compact. 14.44. What is the difference between the highest and the lowest Claims(annual growth as % of broad money) in Lesotho?
Your response must be concise. 10.98. What is the difference between the highest and the lowest Claims(annual growth as % of broad money) in Macedonia?
Your answer should be compact. 24.18. What is the difference between the highest and the lowest Claims(annual growth as % of broad money) of Namibia?
Keep it short and to the point. 12.05. 